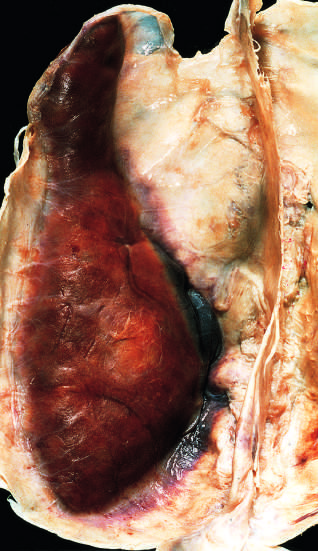what is attached to the dura?
Answer the question using a single word or phrase. Large organizing subdural hematoma 